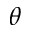Convert formula to latex. <formula><loc_0><loc_0><loc_500><loc_500>\theta</formula> 